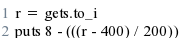<code> <loc_0><loc_0><loc_500><loc_500><_Ruby_>r = gets.to_i
puts 8 - (((r - 400) / 200))</code> 